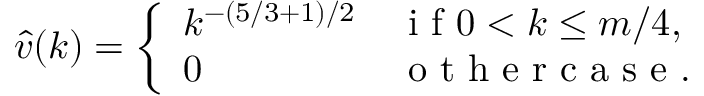<formula> <loc_0><loc_0><loc_500><loc_500>\hat { v } ( k ) = \left \{ \begin{array} { l l } { k ^ { - ( 5 / 3 + 1 ) / 2 } } & { i f 0 < k \leq m / 4 , } \\ { 0 } & { o t h e r c a s e . } \end{array}</formula> 